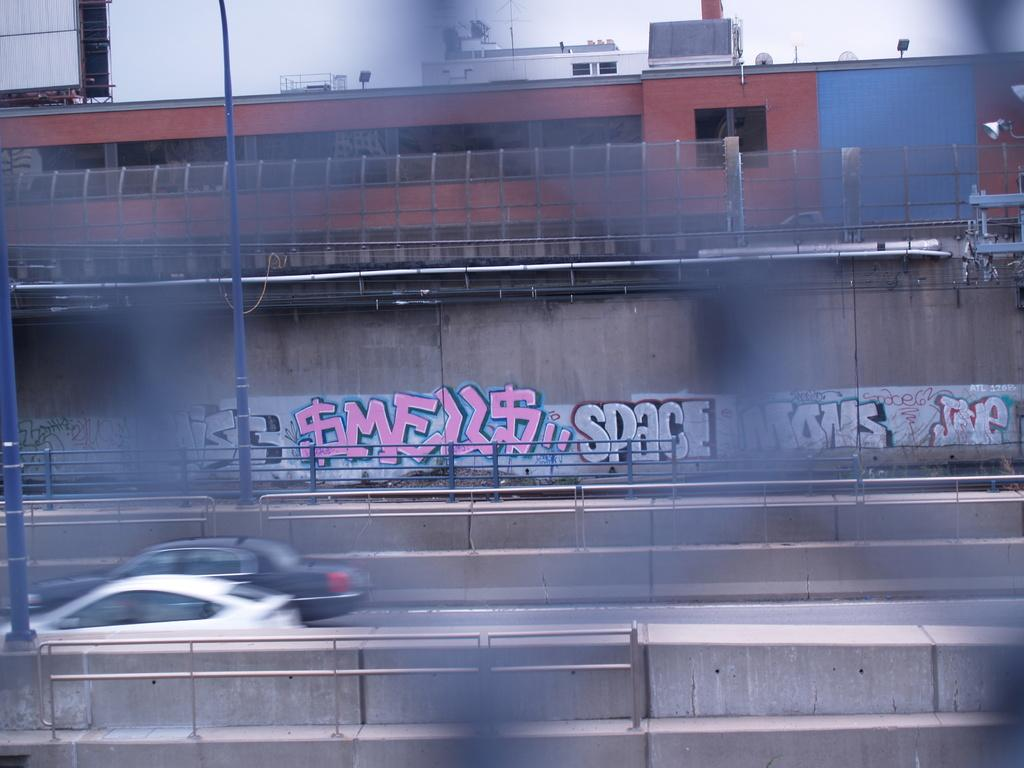<image>
Give a short and clear explanation of the subsequent image. A road with card and graffiti reading "SPACE" painted on the wall. 